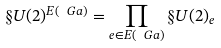Convert formula to latex. <formula><loc_0><loc_0><loc_500><loc_500>\S U ( 2 ) ^ { E ( \ G a ) } = \prod _ { e \in E ( \ G a ) } \S U ( 2 ) _ { e }</formula> 